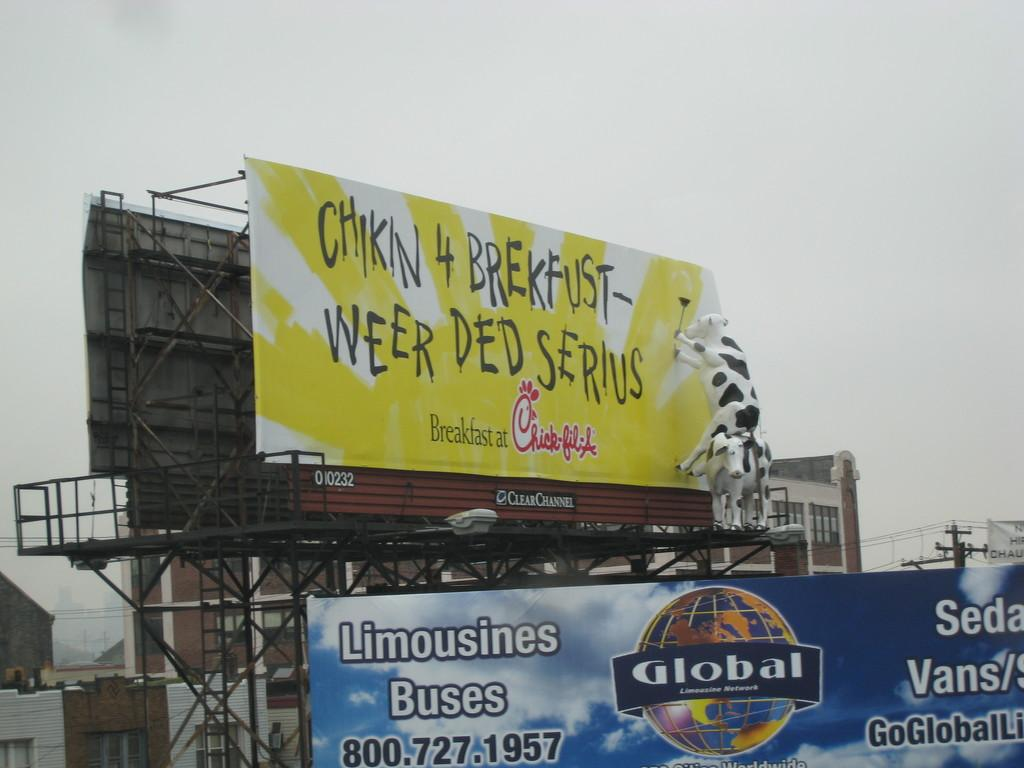<image>
Render a clear and concise summary of the photo. The big yellow billboard is advertising for Chick-fil-A 